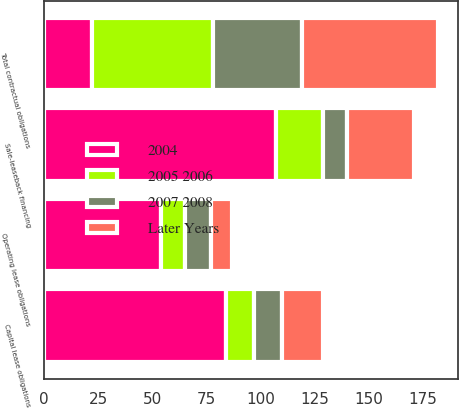<chart> <loc_0><loc_0><loc_500><loc_500><stacked_bar_chart><ecel><fcel>Sale-leaseback financing<fcel>Capital lease obligations<fcel>Operating lease obligations<fcel>Total contractual obligations<nl><fcel>2004<fcel>107<fcel>84<fcel>54<fcel>22<nl><fcel>2007 2008<fcel>11<fcel>13<fcel>12<fcel>41<nl><fcel>2005 2006<fcel>22<fcel>13<fcel>11<fcel>56<nl><fcel>Later Years<fcel>31<fcel>19<fcel>10<fcel>63<nl></chart> 